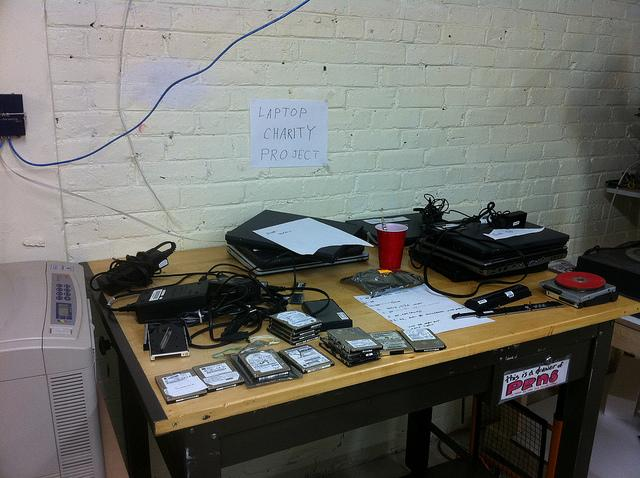What is likely the most valuable object shown? Please explain your reasoning. photocopier. The other electronics are for a charity project. 